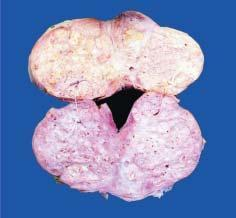does sectioned surface of enlarged prostate show soft to firm, grey-white, nodularity with microcystic areas?
Answer the question using a single word or phrase. Yes 